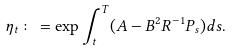Convert formula to latex. <formula><loc_0><loc_0><loc_500><loc_500>\eta _ { t } \colon = \exp \int _ { t } ^ { T } ( A - B ^ { 2 } R ^ { - 1 } P _ { s } ) d s .</formula> 